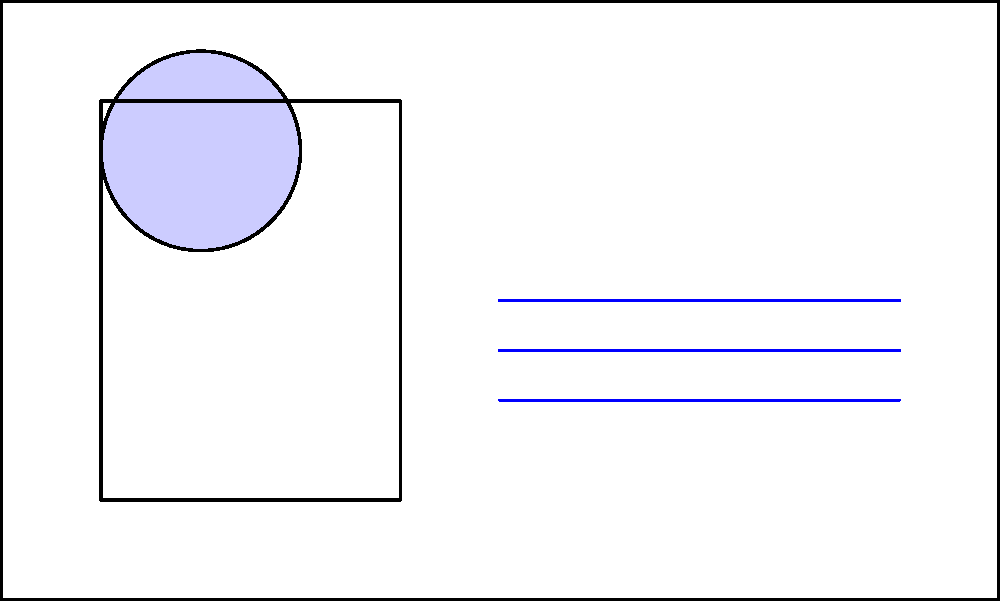In the driver's license design above, which security feature is most effective for quick visual verification and is commonly placed on the photo area? To answer this question, let's analyze the security features present in the driver's license design:

1. Feature A: This circular element represents a hologram. Holograms are difficult to replicate and change appearance when viewed from different angles.

2. Feature B: The blue lines represent microprinting. This involves tiny text that's difficult to reproduce with standard printing methods.

3. Feature C: The green-tinted box represents UV fluorescent ink, which is only visible under ultraviolet light.

Among these features, the hologram (A) is the most effective for quick visual verification:

1. Visibility: Holograms are immediately visible to the naked eye.
2. Difficulty to replicate: They require specialized equipment to produce, making counterfeiting challenging.
3. Dynamic nature: Holograms change appearance when tilted, allowing for quick verification without special tools.
4. Common placement: Holograms are often placed partially overlapping the photo area to integrate the security feature with the identification image.

While microprinting and UV fluorescent ink are valuable security features, they require either magnification or special lighting to verify, making them less suitable for quick visual checks.
Answer: Hologram 